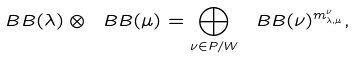<formula> <loc_0><loc_0><loc_500><loc_500>\ B B ( \lambda ) \otimes \ B B ( \mu ) = \bigoplus _ { \nu \in P / W } \ B B ( \nu ) ^ { m _ { \lambda , \mu } ^ { \nu } } ,</formula> 